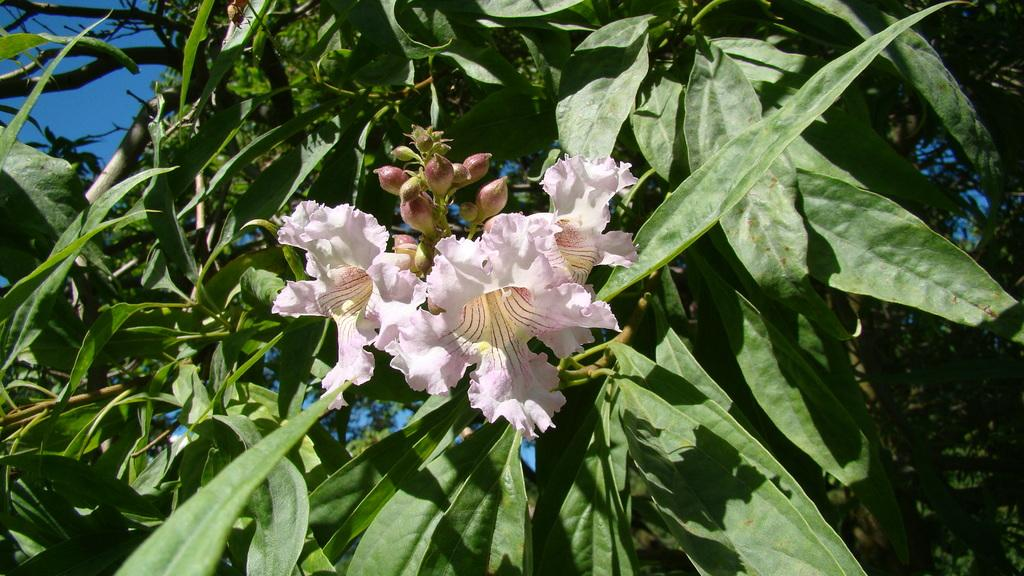What type of animals can be seen in the image? Birds can be seen in the image. What type of plants are in the image? There are flowers and leaves in the image. What is visible in the background of the image? The sky is visible in the background of the image. What is the value of the stranger's transport in the image? There is no stranger or transport present in the image. 